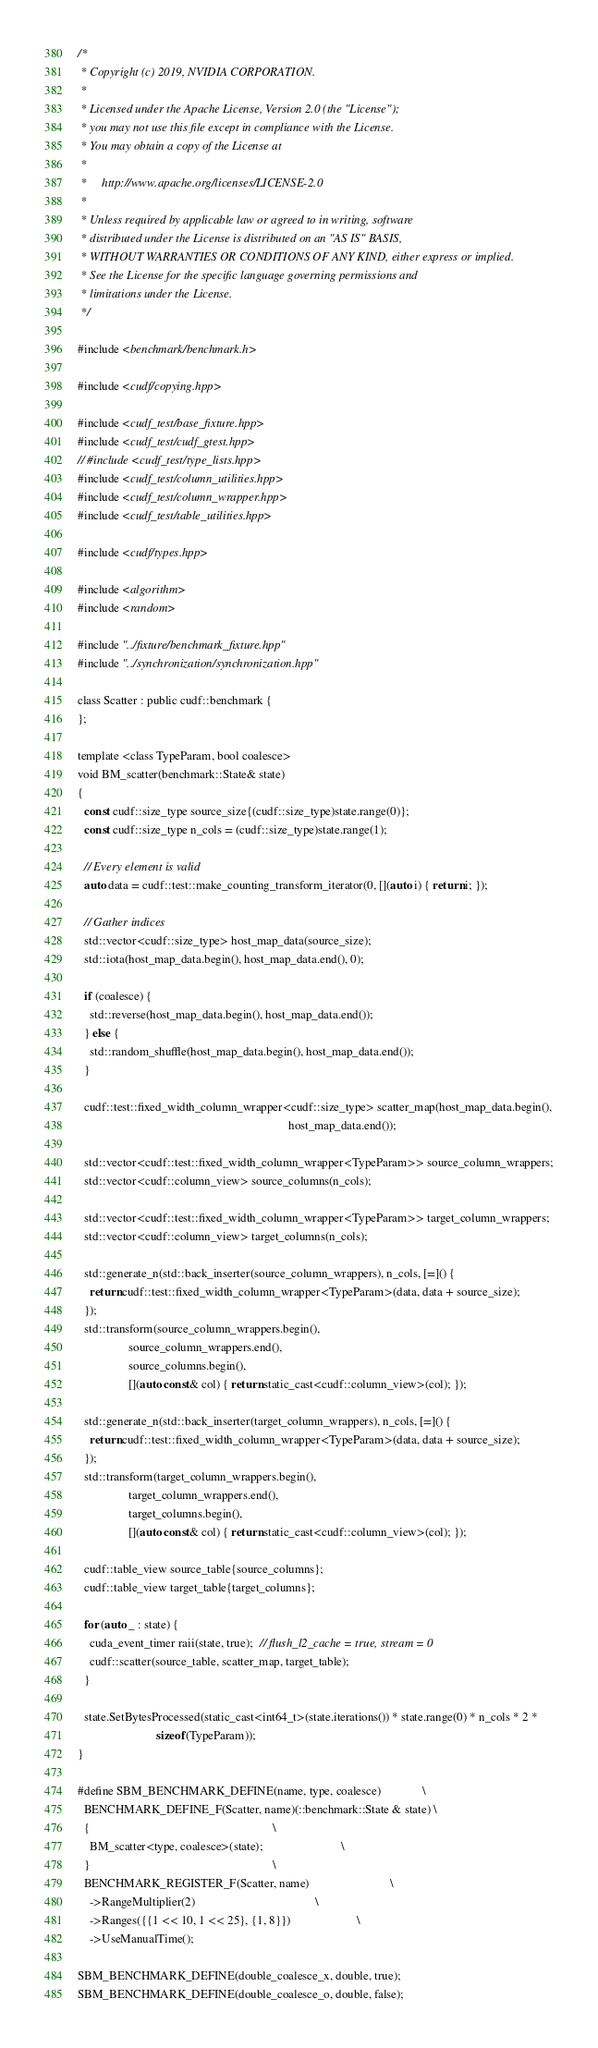Convert code to text. <code><loc_0><loc_0><loc_500><loc_500><_Cuda_>/*
 * Copyright (c) 2019, NVIDIA CORPORATION.
 *
 * Licensed under the Apache License, Version 2.0 (the "License");
 * you may not use this file except in compliance with the License.
 * You may obtain a copy of the License at
 *
 *     http://www.apache.org/licenses/LICENSE-2.0
 *
 * Unless required by applicable law or agreed to in writing, software
 * distributed under the License is distributed on an "AS IS" BASIS,
 * WITHOUT WARRANTIES OR CONDITIONS OF ANY KIND, either express or implied.
 * See the License for the specific language governing permissions and
 * limitations under the License.
 */

#include <benchmark/benchmark.h>

#include <cudf/copying.hpp>

#include <cudf_test/base_fixture.hpp>
#include <cudf_test/cudf_gtest.hpp>
// #include <cudf_test/type_lists.hpp>
#include <cudf_test/column_utilities.hpp>
#include <cudf_test/column_wrapper.hpp>
#include <cudf_test/table_utilities.hpp>

#include <cudf/types.hpp>

#include <algorithm>
#include <random>

#include "../fixture/benchmark_fixture.hpp"
#include "../synchronization/synchronization.hpp"

class Scatter : public cudf::benchmark {
};

template <class TypeParam, bool coalesce>
void BM_scatter(benchmark::State& state)
{
  const cudf::size_type source_size{(cudf::size_type)state.range(0)};
  const cudf::size_type n_cols = (cudf::size_type)state.range(1);

  // Every element is valid
  auto data = cudf::test::make_counting_transform_iterator(0, [](auto i) { return i; });

  // Gather indices
  std::vector<cudf::size_type> host_map_data(source_size);
  std::iota(host_map_data.begin(), host_map_data.end(), 0);

  if (coalesce) {
    std::reverse(host_map_data.begin(), host_map_data.end());
  } else {
    std::random_shuffle(host_map_data.begin(), host_map_data.end());
  }

  cudf::test::fixed_width_column_wrapper<cudf::size_type> scatter_map(host_map_data.begin(),
                                                                      host_map_data.end());

  std::vector<cudf::test::fixed_width_column_wrapper<TypeParam>> source_column_wrappers;
  std::vector<cudf::column_view> source_columns(n_cols);

  std::vector<cudf::test::fixed_width_column_wrapper<TypeParam>> target_column_wrappers;
  std::vector<cudf::column_view> target_columns(n_cols);

  std::generate_n(std::back_inserter(source_column_wrappers), n_cols, [=]() {
    return cudf::test::fixed_width_column_wrapper<TypeParam>(data, data + source_size);
  });
  std::transform(source_column_wrappers.begin(),
                 source_column_wrappers.end(),
                 source_columns.begin(),
                 [](auto const& col) { return static_cast<cudf::column_view>(col); });

  std::generate_n(std::back_inserter(target_column_wrappers), n_cols, [=]() {
    return cudf::test::fixed_width_column_wrapper<TypeParam>(data, data + source_size);
  });
  std::transform(target_column_wrappers.begin(),
                 target_column_wrappers.end(),
                 target_columns.begin(),
                 [](auto const& col) { return static_cast<cudf::column_view>(col); });

  cudf::table_view source_table{source_columns};
  cudf::table_view target_table{target_columns};

  for (auto _ : state) {
    cuda_event_timer raii(state, true);  // flush_l2_cache = true, stream = 0
    cudf::scatter(source_table, scatter_map, target_table);
  }

  state.SetBytesProcessed(static_cast<int64_t>(state.iterations()) * state.range(0) * n_cols * 2 *
                          sizeof(TypeParam));
}

#define SBM_BENCHMARK_DEFINE(name, type, coalesce)              \
  BENCHMARK_DEFINE_F(Scatter, name)(::benchmark::State & state) \
  {                                                             \
    BM_scatter<type, coalesce>(state);                          \
  }                                                             \
  BENCHMARK_REGISTER_F(Scatter, name)                           \
    ->RangeMultiplier(2)                                        \
    ->Ranges({{1 << 10, 1 << 25}, {1, 8}})                      \
    ->UseManualTime();

SBM_BENCHMARK_DEFINE(double_coalesce_x, double, true);
SBM_BENCHMARK_DEFINE(double_coalesce_o, double, false);
</code> 